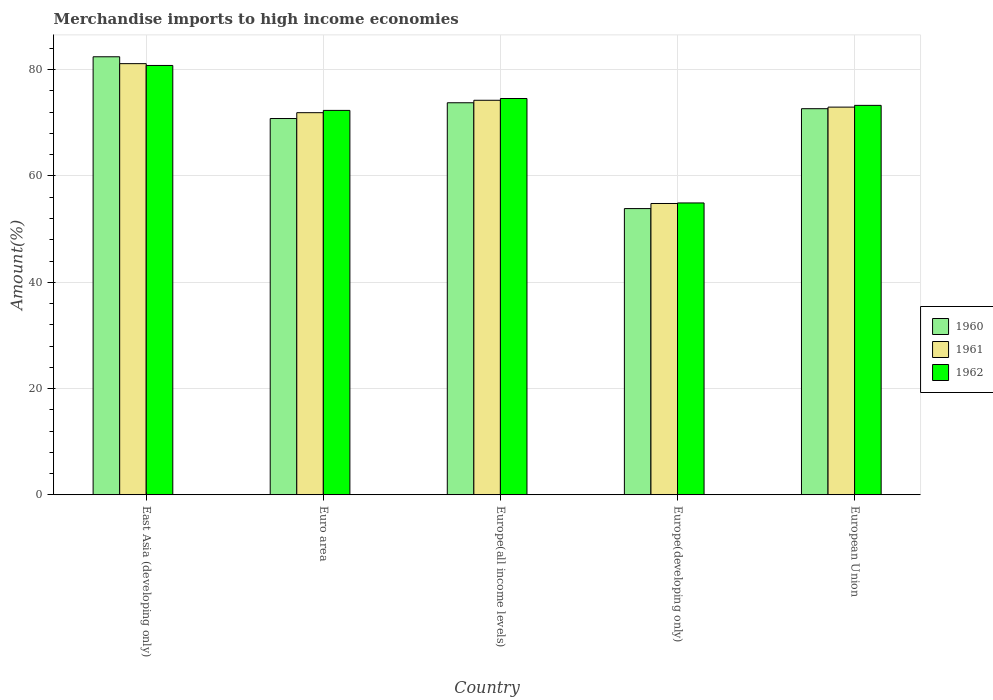How many different coloured bars are there?
Keep it short and to the point. 3. What is the label of the 5th group of bars from the left?
Your response must be concise. European Union. What is the percentage of amount earned from merchandise imports in 1960 in Europe(all income levels)?
Make the answer very short. 73.78. Across all countries, what is the maximum percentage of amount earned from merchandise imports in 1960?
Keep it short and to the point. 82.44. Across all countries, what is the minimum percentage of amount earned from merchandise imports in 1962?
Offer a terse response. 54.93. In which country was the percentage of amount earned from merchandise imports in 1960 maximum?
Your answer should be compact. East Asia (developing only). In which country was the percentage of amount earned from merchandise imports in 1962 minimum?
Ensure brevity in your answer.  Europe(developing only). What is the total percentage of amount earned from merchandise imports in 1962 in the graph?
Provide a succinct answer. 355.94. What is the difference between the percentage of amount earned from merchandise imports in 1962 in Euro area and that in Europe(developing only)?
Offer a terse response. 17.42. What is the difference between the percentage of amount earned from merchandise imports in 1962 in Europe(developing only) and the percentage of amount earned from merchandise imports in 1960 in Euro area?
Provide a succinct answer. -15.89. What is the average percentage of amount earned from merchandise imports in 1962 per country?
Offer a very short reply. 71.19. What is the difference between the percentage of amount earned from merchandise imports of/in 1960 and percentage of amount earned from merchandise imports of/in 1962 in Europe(all income levels)?
Keep it short and to the point. -0.8. What is the ratio of the percentage of amount earned from merchandise imports in 1961 in Europe(all income levels) to that in European Union?
Give a very brief answer. 1.02. Is the difference between the percentage of amount earned from merchandise imports in 1960 in East Asia (developing only) and Europe(developing only) greater than the difference between the percentage of amount earned from merchandise imports in 1962 in East Asia (developing only) and Europe(developing only)?
Keep it short and to the point. Yes. What is the difference between the highest and the second highest percentage of amount earned from merchandise imports in 1962?
Offer a very short reply. 7.51. What is the difference between the highest and the lowest percentage of amount earned from merchandise imports in 1960?
Your answer should be very brief. 28.57. What does the 2nd bar from the left in Europe(developing only) represents?
Your answer should be very brief. 1961. What does the 1st bar from the right in European Union represents?
Your answer should be very brief. 1962. How many countries are there in the graph?
Provide a succinct answer. 5. What is the difference between two consecutive major ticks on the Y-axis?
Keep it short and to the point. 20. Does the graph contain grids?
Make the answer very short. Yes. What is the title of the graph?
Provide a succinct answer. Merchandise imports to high income economies. Does "2005" appear as one of the legend labels in the graph?
Ensure brevity in your answer.  No. What is the label or title of the Y-axis?
Make the answer very short. Amount(%). What is the Amount(%) of 1960 in East Asia (developing only)?
Your answer should be compact. 82.44. What is the Amount(%) of 1961 in East Asia (developing only)?
Your response must be concise. 81.14. What is the Amount(%) of 1962 in East Asia (developing only)?
Make the answer very short. 80.8. What is the Amount(%) of 1960 in Euro area?
Provide a short and direct response. 70.81. What is the Amount(%) in 1961 in Euro area?
Make the answer very short. 71.91. What is the Amount(%) in 1962 in Euro area?
Provide a short and direct response. 72.34. What is the Amount(%) of 1960 in Europe(all income levels)?
Provide a short and direct response. 73.78. What is the Amount(%) in 1961 in Europe(all income levels)?
Provide a short and direct response. 74.25. What is the Amount(%) of 1962 in Europe(all income levels)?
Provide a succinct answer. 74.58. What is the Amount(%) in 1960 in Europe(developing only)?
Give a very brief answer. 53.86. What is the Amount(%) of 1961 in Europe(developing only)?
Provide a short and direct response. 54.82. What is the Amount(%) of 1962 in Europe(developing only)?
Your answer should be compact. 54.93. What is the Amount(%) of 1960 in European Union?
Provide a succinct answer. 72.67. What is the Amount(%) of 1961 in European Union?
Provide a short and direct response. 72.96. What is the Amount(%) of 1962 in European Union?
Offer a terse response. 73.29. Across all countries, what is the maximum Amount(%) of 1960?
Your answer should be very brief. 82.44. Across all countries, what is the maximum Amount(%) of 1961?
Offer a very short reply. 81.14. Across all countries, what is the maximum Amount(%) in 1962?
Provide a succinct answer. 80.8. Across all countries, what is the minimum Amount(%) of 1960?
Offer a very short reply. 53.86. Across all countries, what is the minimum Amount(%) of 1961?
Your answer should be very brief. 54.82. Across all countries, what is the minimum Amount(%) of 1962?
Your answer should be very brief. 54.93. What is the total Amount(%) of 1960 in the graph?
Make the answer very short. 353.56. What is the total Amount(%) of 1961 in the graph?
Offer a very short reply. 355.09. What is the total Amount(%) in 1962 in the graph?
Offer a very short reply. 355.94. What is the difference between the Amount(%) of 1960 in East Asia (developing only) and that in Euro area?
Make the answer very short. 11.62. What is the difference between the Amount(%) of 1961 in East Asia (developing only) and that in Euro area?
Offer a terse response. 9.23. What is the difference between the Amount(%) of 1962 in East Asia (developing only) and that in Euro area?
Give a very brief answer. 8.46. What is the difference between the Amount(%) in 1960 in East Asia (developing only) and that in Europe(all income levels)?
Provide a succinct answer. 8.65. What is the difference between the Amount(%) in 1961 in East Asia (developing only) and that in Europe(all income levels)?
Offer a terse response. 6.89. What is the difference between the Amount(%) of 1962 in East Asia (developing only) and that in Europe(all income levels)?
Offer a terse response. 6.22. What is the difference between the Amount(%) in 1960 in East Asia (developing only) and that in Europe(developing only)?
Your answer should be compact. 28.57. What is the difference between the Amount(%) of 1961 in East Asia (developing only) and that in Europe(developing only)?
Your response must be concise. 26.32. What is the difference between the Amount(%) of 1962 in East Asia (developing only) and that in Europe(developing only)?
Your answer should be compact. 25.88. What is the difference between the Amount(%) of 1960 in East Asia (developing only) and that in European Union?
Your response must be concise. 9.77. What is the difference between the Amount(%) in 1961 in East Asia (developing only) and that in European Union?
Your response must be concise. 8.18. What is the difference between the Amount(%) of 1962 in East Asia (developing only) and that in European Union?
Ensure brevity in your answer.  7.51. What is the difference between the Amount(%) in 1960 in Euro area and that in Europe(all income levels)?
Your answer should be compact. -2.97. What is the difference between the Amount(%) in 1961 in Euro area and that in Europe(all income levels)?
Provide a succinct answer. -2.33. What is the difference between the Amount(%) of 1962 in Euro area and that in Europe(all income levels)?
Provide a short and direct response. -2.24. What is the difference between the Amount(%) in 1960 in Euro area and that in Europe(developing only)?
Make the answer very short. 16.95. What is the difference between the Amount(%) of 1961 in Euro area and that in Europe(developing only)?
Ensure brevity in your answer.  17.09. What is the difference between the Amount(%) in 1962 in Euro area and that in Europe(developing only)?
Your answer should be very brief. 17.42. What is the difference between the Amount(%) in 1960 in Euro area and that in European Union?
Give a very brief answer. -1.85. What is the difference between the Amount(%) of 1961 in Euro area and that in European Union?
Your answer should be compact. -1.05. What is the difference between the Amount(%) of 1962 in Euro area and that in European Union?
Provide a short and direct response. -0.95. What is the difference between the Amount(%) of 1960 in Europe(all income levels) and that in Europe(developing only)?
Your response must be concise. 19.92. What is the difference between the Amount(%) of 1961 in Europe(all income levels) and that in Europe(developing only)?
Your answer should be very brief. 19.42. What is the difference between the Amount(%) of 1962 in Europe(all income levels) and that in Europe(developing only)?
Your answer should be compact. 19.66. What is the difference between the Amount(%) in 1960 in Europe(all income levels) and that in European Union?
Your answer should be compact. 1.12. What is the difference between the Amount(%) in 1961 in Europe(all income levels) and that in European Union?
Ensure brevity in your answer.  1.29. What is the difference between the Amount(%) in 1962 in Europe(all income levels) and that in European Union?
Your response must be concise. 1.29. What is the difference between the Amount(%) of 1960 in Europe(developing only) and that in European Union?
Provide a short and direct response. -18.8. What is the difference between the Amount(%) in 1961 in Europe(developing only) and that in European Union?
Your answer should be very brief. -18.14. What is the difference between the Amount(%) in 1962 in Europe(developing only) and that in European Union?
Give a very brief answer. -18.37. What is the difference between the Amount(%) in 1960 in East Asia (developing only) and the Amount(%) in 1961 in Euro area?
Provide a succinct answer. 10.52. What is the difference between the Amount(%) in 1960 in East Asia (developing only) and the Amount(%) in 1962 in Euro area?
Make the answer very short. 10.09. What is the difference between the Amount(%) in 1961 in East Asia (developing only) and the Amount(%) in 1962 in Euro area?
Provide a succinct answer. 8.8. What is the difference between the Amount(%) of 1960 in East Asia (developing only) and the Amount(%) of 1961 in Europe(all income levels)?
Ensure brevity in your answer.  8.19. What is the difference between the Amount(%) of 1960 in East Asia (developing only) and the Amount(%) of 1962 in Europe(all income levels)?
Keep it short and to the point. 7.85. What is the difference between the Amount(%) of 1961 in East Asia (developing only) and the Amount(%) of 1962 in Europe(all income levels)?
Keep it short and to the point. 6.56. What is the difference between the Amount(%) in 1960 in East Asia (developing only) and the Amount(%) in 1961 in Europe(developing only)?
Your response must be concise. 27.61. What is the difference between the Amount(%) in 1960 in East Asia (developing only) and the Amount(%) in 1962 in Europe(developing only)?
Provide a succinct answer. 27.51. What is the difference between the Amount(%) in 1961 in East Asia (developing only) and the Amount(%) in 1962 in Europe(developing only)?
Your answer should be compact. 26.22. What is the difference between the Amount(%) in 1960 in East Asia (developing only) and the Amount(%) in 1961 in European Union?
Your answer should be very brief. 9.48. What is the difference between the Amount(%) of 1960 in East Asia (developing only) and the Amount(%) of 1962 in European Union?
Give a very brief answer. 9.14. What is the difference between the Amount(%) in 1961 in East Asia (developing only) and the Amount(%) in 1962 in European Union?
Provide a succinct answer. 7.85. What is the difference between the Amount(%) of 1960 in Euro area and the Amount(%) of 1961 in Europe(all income levels)?
Offer a terse response. -3.43. What is the difference between the Amount(%) in 1960 in Euro area and the Amount(%) in 1962 in Europe(all income levels)?
Your response must be concise. -3.77. What is the difference between the Amount(%) of 1961 in Euro area and the Amount(%) of 1962 in Europe(all income levels)?
Your answer should be very brief. -2.67. What is the difference between the Amount(%) in 1960 in Euro area and the Amount(%) in 1961 in Europe(developing only)?
Your answer should be very brief. 15.99. What is the difference between the Amount(%) in 1960 in Euro area and the Amount(%) in 1962 in Europe(developing only)?
Your answer should be very brief. 15.89. What is the difference between the Amount(%) in 1961 in Euro area and the Amount(%) in 1962 in Europe(developing only)?
Keep it short and to the point. 16.99. What is the difference between the Amount(%) of 1960 in Euro area and the Amount(%) of 1961 in European Union?
Give a very brief answer. -2.14. What is the difference between the Amount(%) of 1960 in Euro area and the Amount(%) of 1962 in European Union?
Give a very brief answer. -2.48. What is the difference between the Amount(%) of 1961 in Euro area and the Amount(%) of 1962 in European Union?
Provide a succinct answer. -1.38. What is the difference between the Amount(%) of 1960 in Europe(all income levels) and the Amount(%) of 1961 in Europe(developing only)?
Provide a succinct answer. 18.96. What is the difference between the Amount(%) of 1960 in Europe(all income levels) and the Amount(%) of 1962 in Europe(developing only)?
Provide a succinct answer. 18.86. What is the difference between the Amount(%) of 1961 in Europe(all income levels) and the Amount(%) of 1962 in Europe(developing only)?
Your response must be concise. 19.32. What is the difference between the Amount(%) in 1960 in Europe(all income levels) and the Amount(%) in 1961 in European Union?
Your answer should be compact. 0.82. What is the difference between the Amount(%) of 1960 in Europe(all income levels) and the Amount(%) of 1962 in European Union?
Make the answer very short. 0.49. What is the difference between the Amount(%) of 1961 in Europe(all income levels) and the Amount(%) of 1962 in European Union?
Your response must be concise. 0.96. What is the difference between the Amount(%) of 1960 in Europe(developing only) and the Amount(%) of 1961 in European Union?
Your answer should be very brief. -19.09. What is the difference between the Amount(%) in 1960 in Europe(developing only) and the Amount(%) in 1962 in European Union?
Make the answer very short. -19.43. What is the difference between the Amount(%) in 1961 in Europe(developing only) and the Amount(%) in 1962 in European Union?
Your answer should be compact. -18.47. What is the average Amount(%) in 1960 per country?
Ensure brevity in your answer.  70.71. What is the average Amount(%) of 1961 per country?
Your answer should be very brief. 71.02. What is the average Amount(%) of 1962 per country?
Provide a short and direct response. 71.19. What is the difference between the Amount(%) in 1960 and Amount(%) in 1961 in East Asia (developing only)?
Your answer should be compact. 1.29. What is the difference between the Amount(%) of 1960 and Amount(%) of 1962 in East Asia (developing only)?
Offer a very short reply. 1.63. What is the difference between the Amount(%) in 1961 and Amount(%) in 1962 in East Asia (developing only)?
Give a very brief answer. 0.34. What is the difference between the Amount(%) of 1960 and Amount(%) of 1961 in Euro area?
Your answer should be very brief. -1.1. What is the difference between the Amount(%) in 1960 and Amount(%) in 1962 in Euro area?
Offer a terse response. -1.53. What is the difference between the Amount(%) in 1961 and Amount(%) in 1962 in Euro area?
Provide a succinct answer. -0.43. What is the difference between the Amount(%) in 1960 and Amount(%) in 1961 in Europe(all income levels)?
Give a very brief answer. -0.47. What is the difference between the Amount(%) in 1960 and Amount(%) in 1962 in Europe(all income levels)?
Offer a very short reply. -0.8. What is the difference between the Amount(%) in 1961 and Amount(%) in 1962 in Europe(all income levels)?
Your answer should be compact. -0.33. What is the difference between the Amount(%) of 1960 and Amount(%) of 1961 in Europe(developing only)?
Offer a terse response. -0.96. What is the difference between the Amount(%) in 1960 and Amount(%) in 1962 in Europe(developing only)?
Give a very brief answer. -1.06. What is the difference between the Amount(%) in 1961 and Amount(%) in 1962 in Europe(developing only)?
Give a very brief answer. -0.1. What is the difference between the Amount(%) of 1960 and Amount(%) of 1961 in European Union?
Provide a short and direct response. -0.29. What is the difference between the Amount(%) in 1960 and Amount(%) in 1962 in European Union?
Your response must be concise. -0.63. What is the difference between the Amount(%) in 1961 and Amount(%) in 1962 in European Union?
Your answer should be very brief. -0.33. What is the ratio of the Amount(%) of 1960 in East Asia (developing only) to that in Euro area?
Your answer should be compact. 1.16. What is the ratio of the Amount(%) in 1961 in East Asia (developing only) to that in Euro area?
Provide a short and direct response. 1.13. What is the ratio of the Amount(%) in 1962 in East Asia (developing only) to that in Euro area?
Provide a succinct answer. 1.12. What is the ratio of the Amount(%) in 1960 in East Asia (developing only) to that in Europe(all income levels)?
Provide a succinct answer. 1.12. What is the ratio of the Amount(%) in 1961 in East Asia (developing only) to that in Europe(all income levels)?
Offer a very short reply. 1.09. What is the ratio of the Amount(%) in 1962 in East Asia (developing only) to that in Europe(all income levels)?
Offer a terse response. 1.08. What is the ratio of the Amount(%) in 1960 in East Asia (developing only) to that in Europe(developing only)?
Ensure brevity in your answer.  1.53. What is the ratio of the Amount(%) of 1961 in East Asia (developing only) to that in Europe(developing only)?
Keep it short and to the point. 1.48. What is the ratio of the Amount(%) of 1962 in East Asia (developing only) to that in Europe(developing only)?
Provide a short and direct response. 1.47. What is the ratio of the Amount(%) of 1960 in East Asia (developing only) to that in European Union?
Your response must be concise. 1.13. What is the ratio of the Amount(%) in 1961 in East Asia (developing only) to that in European Union?
Your response must be concise. 1.11. What is the ratio of the Amount(%) of 1962 in East Asia (developing only) to that in European Union?
Your response must be concise. 1.1. What is the ratio of the Amount(%) of 1960 in Euro area to that in Europe(all income levels)?
Provide a succinct answer. 0.96. What is the ratio of the Amount(%) of 1961 in Euro area to that in Europe(all income levels)?
Your response must be concise. 0.97. What is the ratio of the Amount(%) in 1962 in Euro area to that in Europe(all income levels)?
Offer a terse response. 0.97. What is the ratio of the Amount(%) in 1960 in Euro area to that in Europe(developing only)?
Your response must be concise. 1.31. What is the ratio of the Amount(%) in 1961 in Euro area to that in Europe(developing only)?
Give a very brief answer. 1.31. What is the ratio of the Amount(%) in 1962 in Euro area to that in Europe(developing only)?
Keep it short and to the point. 1.32. What is the ratio of the Amount(%) in 1960 in Euro area to that in European Union?
Offer a very short reply. 0.97. What is the ratio of the Amount(%) in 1961 in Euro area to that in European Union?
Your response must be concise. 0.99. What is the ratio of the Amount(%) of 1962 in Euro area to that in European Union?
Your response must be concise. 0.99. What is the ratio of the Amount(%) of 1960 in Europe(all income levels) to that in Europe(developing only)?
Ensure brevity in your answer.  1.37. What is the ratio of the Amount(%) in 1961 in Europe(all income levels) to that in Europe(developing only)?
Your response must be concise. 1.35. What is the ratio of the Amount(%) of 1962 in Europe(all income levels) to that in Europe(developing only)?
Keep it short and to the point. 1.36. What is the ratio of the Amount(%) of 1960 in Europe(all income levels) to that in European Union?
Give a very brief answer. 1.02. What is the ratio of the Amount(%) in 1961 in Europe(all income levels) to that in European Union?
Offer a very short reply. 1.02. What is the ratio of the Amount(%) of 1962 in Europe(all income levels) to that in European Union?
Ensure brevity in your answer.  1.02. What is the ratio of the Amount(%) of 1960 in Europe(developing only) to that in European Union?
Offer a terse response. 0.74. What is the ratio of the Amount(%) in 1961 in Europe(developing only) to that in European Union?
Ensure brevity in your answer.  0.75. What is the ratio of the Amount(%) of 1962 in Europe(developing only) to that in European Union?
Offer a very short reply. 0.75. What is the difference between the highest and the second highest Amount(%) of 1960?
Your answer should be very brief. 8.65. What is the difference between the highest and the second highest Amount(%) of 1961?
Your response must be concise. 6.89. What is the difference between the highest and the second highest Amount(%) of 1962?
Offer a very short reply. 6.22. What is the difference between the highest and the lowest Amount(%) in 1960?
Keep it short and to the point. 28.57. What is the difference between the highest and the lowest Amount(%) in 1961?
Keep it short and to the point. 26.32. What is the difference between the highest and the lowest Amount(%) of 1962?
Provide a short and direct response. 25.88. 